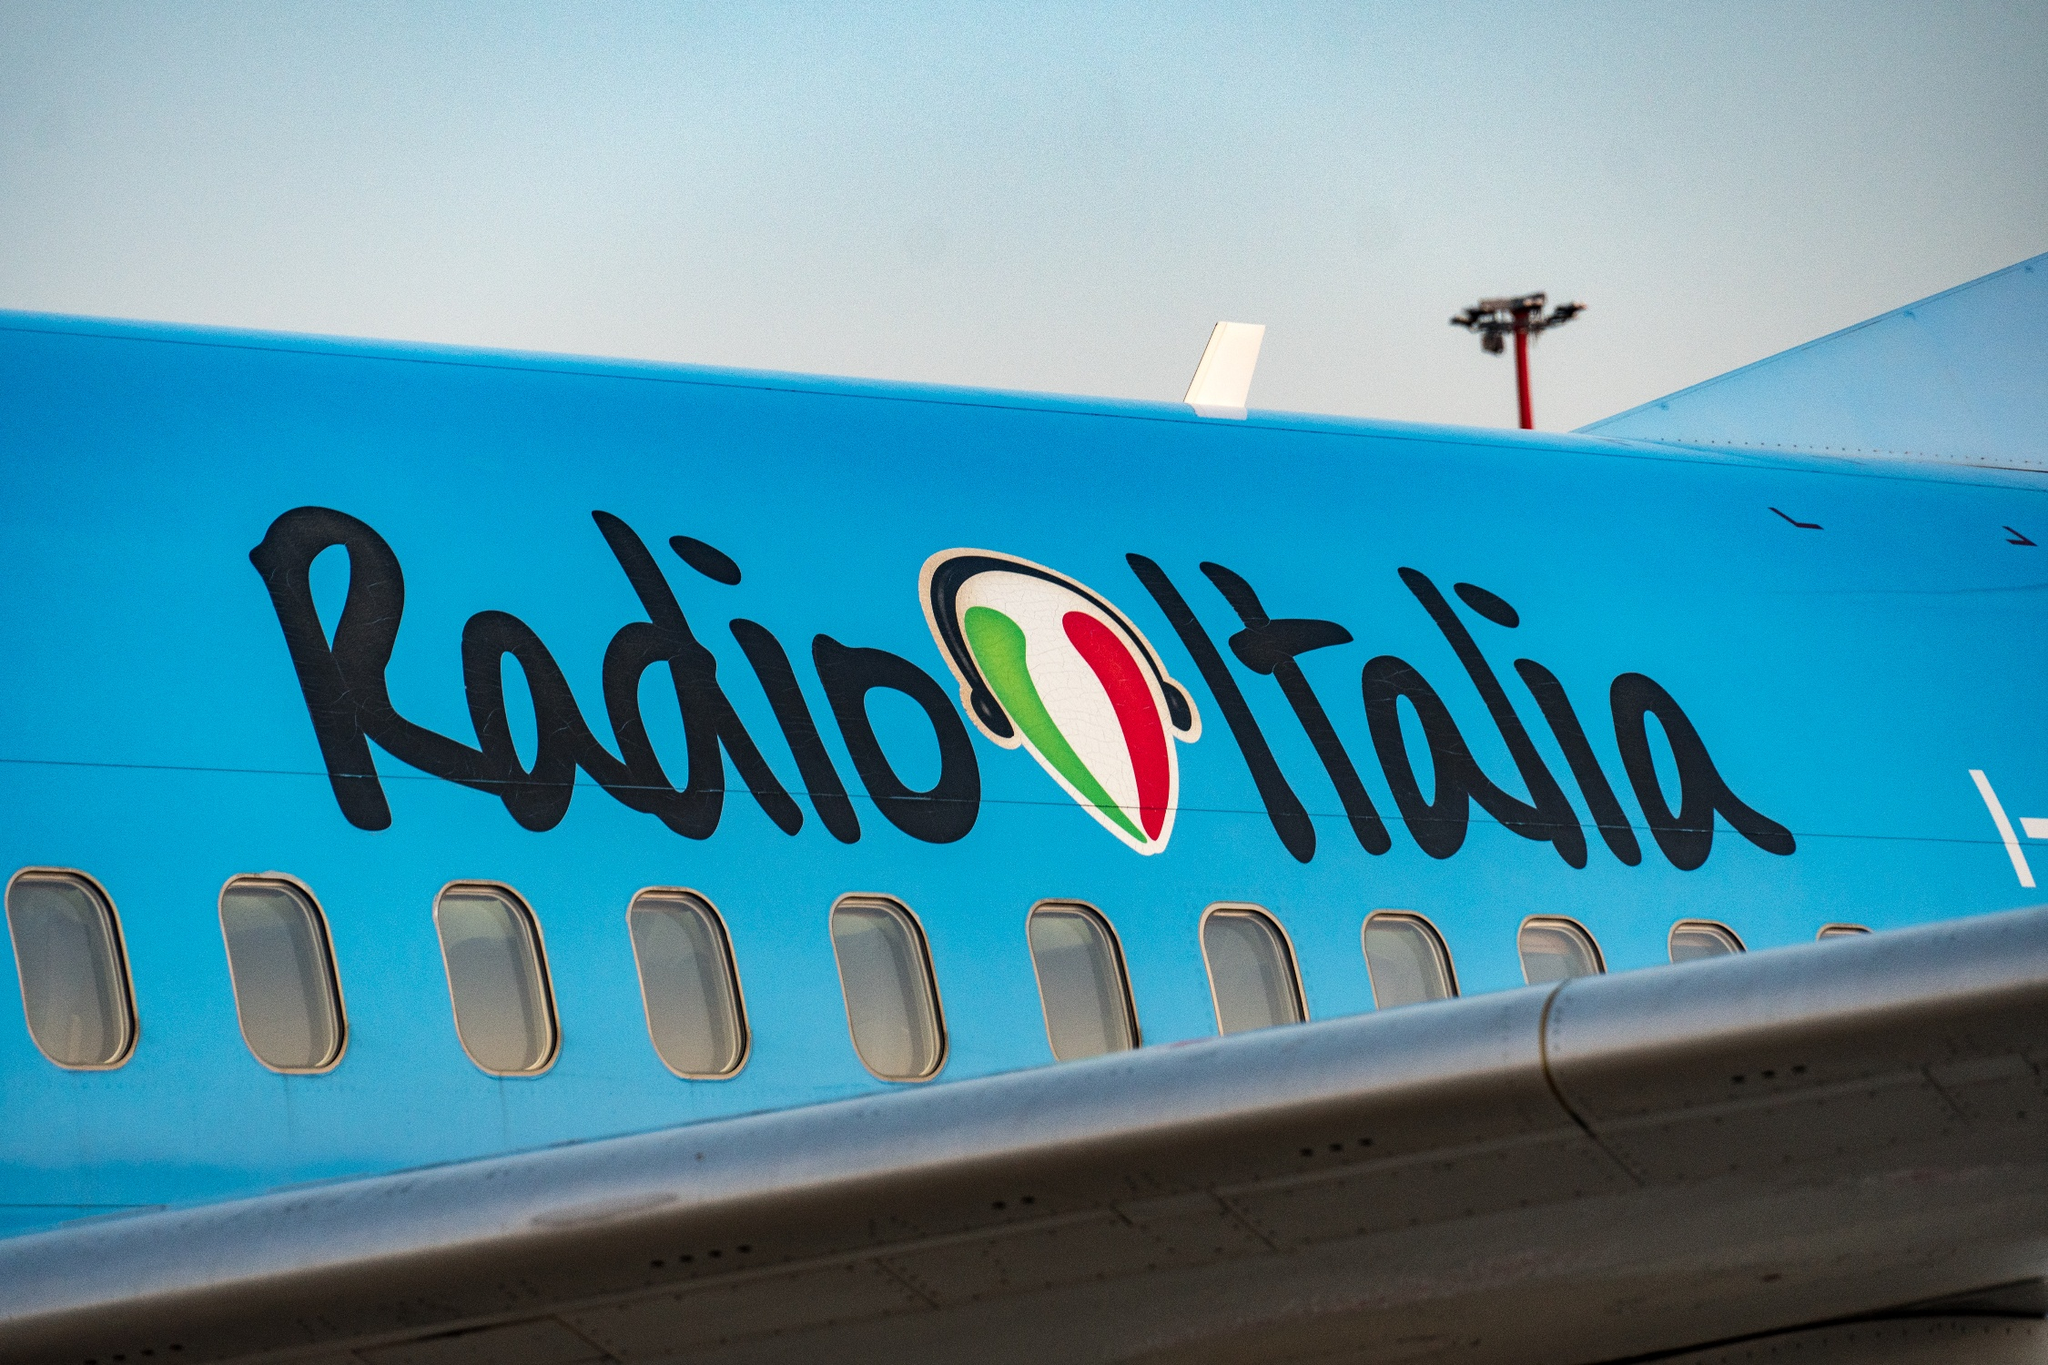Describe the following image. The image spotlights a vivid blue airplane adorned with the inscription 'Radio Italia' in elegant, black cursive script on its fuselage. Adjacent to the text, the logo resembling an artistic representation of the Italian flag—red, white, and green—is prominently displayed. This view, taken from a low-angle perspective, emphasizes the imposing stature of the airplane against a broad, tranquil sky. Details such as a solitary light pole peeking in the top right corner add an urban flair to the composition, bridging elements of modern technology with metropolitan life. 